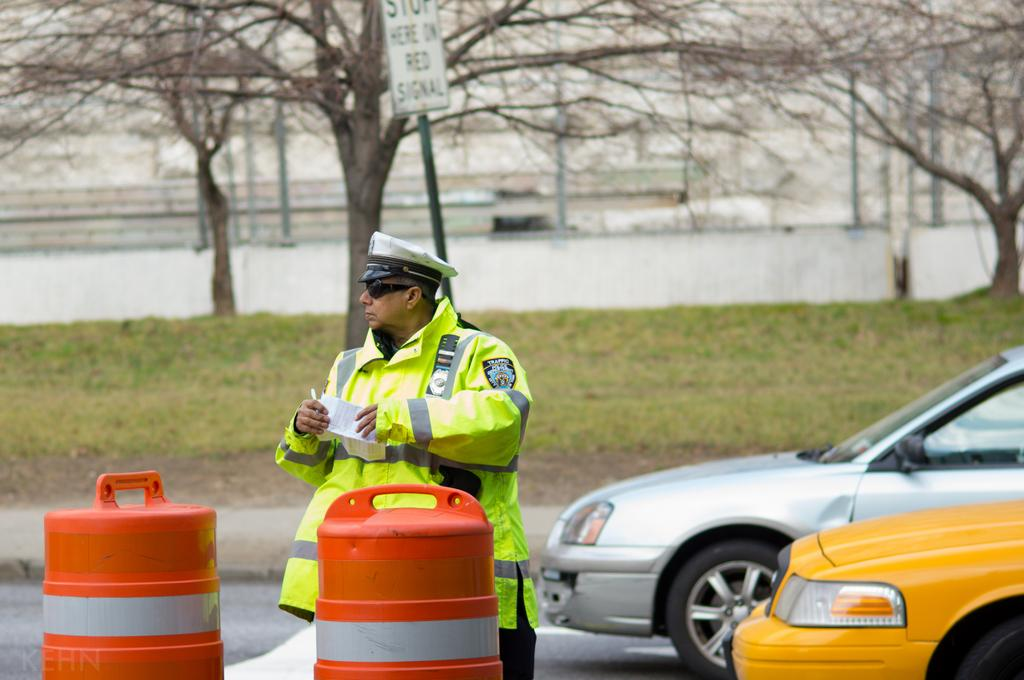<image>
Render a clear and concise summary of the photo. a cop that has the word traffic on his sleeve 